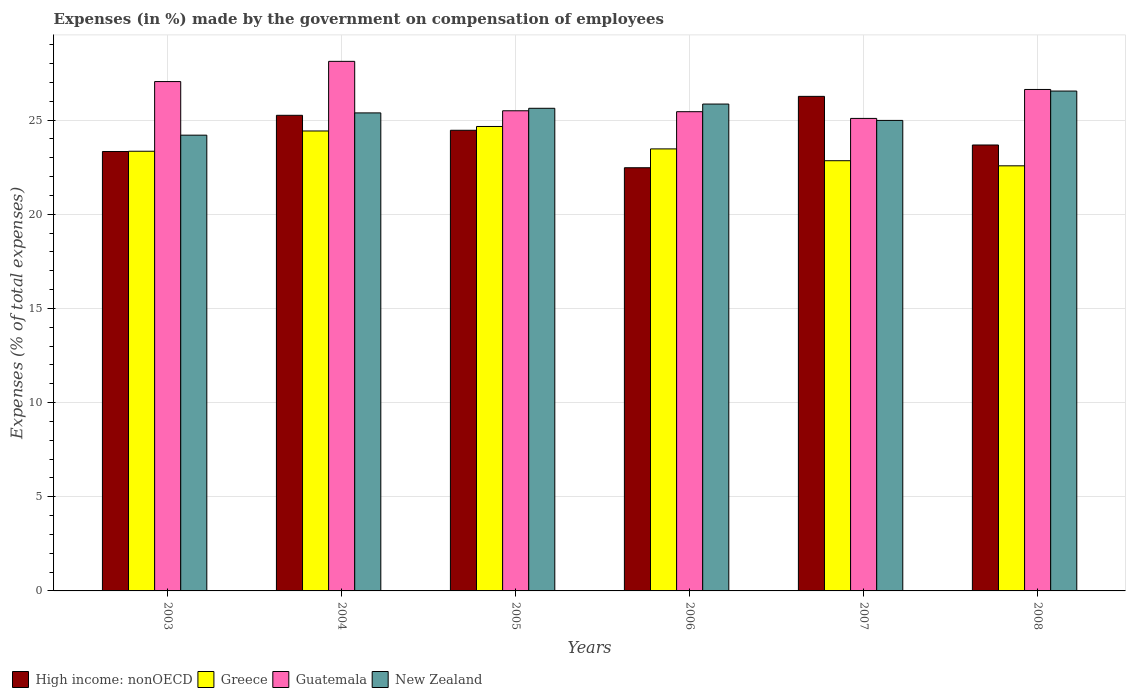How many different coloured bars are there?
Make the answer very short. 4. How many groups of bars are there?
Provide a short and direct response. 6. Are the number of bars per tick equal to the number of legend labels?
Your answer should be very brief. Yes. Are the number of bars on each tick of the X-axis equal?
Your response must be concise. Yes. How many bars are there on the 3rd tick from the left?
Offer a very short reply. 4. How many bars are there on the 3rd tick from the right?
Your answer should be compact. 4. In how many cases, is the number of bars for a given year not equal to the number of legend labels?
Ensure brevity in your answer.  0. What is the percentage of expenses made by the government on compensation of employees in Guatemala in 2005?
Give a very brief answer. 25.49. Across all years, what is the maximum percentage of expenses made by the government on compensation of employees in Greece?
Provide a short and direct response. 24.66. Across all years, what is the minimum percentage of expenses made by the government on compensation of employees in New Zealand?
Ensure brevity in your answer.  24.2. In which year was the percentage of expenses made by the government on compensation of employees in Guatemala maximum?
Provide a succinct answer. 2004. In which year was the percentage of expenses made by the government on compensation of employees in Guatemala minimum?
Keep it short and to the point. 2007. What is the total percentage of expenses made by the government on compensation of employees in Greece in the graph?
Offer a terse response. 141.3. What is the difference between the percentage of expenses made by the government on compensation of employees in High income: nonOECD in 2003 and that in 2004?
Provide a succinct answer. -1.92. What is the difference between the percentage of expenses made by the government on compensation of employees in New Zealand in 2007 and the percentage of expenses made by the government on compensation of employees in Guatemala in 2004?
Give a very brief answer. -3.14. What is the average percentage of expenses made by the government on compensation of employees in High income: nonOECD per year?
Give a very brief answer. 24.24. In the year 2005, what is the difference between the percentage of expenses made by the government on compensation of employees in New Zealand and percentage of expenses made by the government on compensation of employees in Greece?
Make the answer very short. 0.97. What is the ratio of the percentage of expenses made by the government on compensation of employees in New Zealand in 2003 to that in 2006?
Offer a terse response. 0.94. Is the percentage of expenses made by the government on compensation of employees in Greece in 2003 less than that in 2007?
Offer a very short reply. No. Is the difference between the percentage of expenses made by the government on compensation of employees in New Zealand in 2006 and 2008 greater than the difference between the percentage of expenses made by the government on compensation of employees in Greece in 2006 and 2008?
Offer a very short reply. No. What is the difference between the highest and the second highest percentage of expenses made by the government on compensation of employees in Greece?
Your answer should be very brief. 0.24. What is the difference between the highest and the lowest percentage of expenses made by the government on compensation of employees in High income: nonOECD?
Your response must be concise. 3.79. In how many years, is the percentage of expenses made by the government on compensation of employees in New Zealand greater than the average percentage of expenses made by the government on compensation of employees in New Zealand taken over all years?
Keep it short and to the point. 3. Is the sum of the percentage of expenses made by the government on compensation of employees in High income: nonOECD in 2003 and 2004 greater than the maximum percentage of expenses made by the government on compensation of employees in Greece across all years?
Your response must be concise. Yes. What does the 3rd bar from the left in 2007 represents?
Your answer should be very brief. Guatemala. What does the 1st bar from the right in 2003 represents?
Your response must be concise. New Zealand. What is the difference between two consecutive major ticks on the Y-axis?
Provide a short and direct response. 5. Does the graph contain grids?
Your answer should be compact. Yes. Where does the legend appear in the graph?
Your response must be concise. Bottom left. What is the title of the graph?
Provide a succinct answer. Expenses (in %) made by the government on compensation of employees. Does "Papua New Guinea" appear as one of the legend labels in the graph?
Ensure brevity in your answer.  No. What is the label or title of the X-axis?
Ensure brevity in your answer.  Years. What is the label or title of the Y-axis?
Your answer should be compact. Expenses (% of total expenses). What is the Expenses (% of total expenses) of High income: nonOECD in 2003?
Provide a short and direct response. 23.33. What is the Expenses (% of total expenses) of Greece in 2003?
Provide a short and direct response. 23.34. What is the Expenses (% of total expenses) of Guatemala in 2003?
Provide a succinct answer. 27.04. What is the Expenses (% of total expenses) of New Zealand in 2003?
Provide a short and direct response. 24.2. What is the Expenses (% of total expenses) of High income: nonOECD in 2004?
Provide a short and direct response. 25.25. What is the Expenses (% of total expenses) of Greece in 2004?
Give a very brief answer. 24.42. What is the Expenses (% of total expenses) in Guatemala in 2004?
Give a very brief answer. 28.12. What is the Expenses (% of total expenses) of New Zealand in 2004?
Offer a terse response. 25.38. What is the Expenses (% of total expenses) of High income: nonOECD in 2005?
Your answer should be compact. 24.46. What is the Expenses (% of total expenses) of Greece in 2005?
Your answer should be compact. 24.66. What is the Expenses (% of total expenses) of Guatemala in 2005?
Give a very brief answer. 25.49. What is the Expenses (% of total expenses) in New Zealand in 2005?
Your response must be concise. 25.62. What is the Expenses (% of total expenses) of High income: nonOECD in 2006?
Make the answer very short. 22.47. What is the Expenses (% of total expenses) in Greece in 2006?
Provide a short and direct response. 23.47. What is the Expenses (% of total expenses) in Guatemala in 2006?
Provide a short and direct response. 25.44. What is the Expenses (% of total expenses) in New Zealand in 2006?
Ensure brevity in your answer.  25.85. What is the Expenses (% of total expenses) of High income: nonOECD in 2007?
Give a very brief answer. 26.26. What is the Expenses (% of total expenses) in Greece in 2007?
Offer a very short reply. 22.84. What is the Expenses (% of total expenses) of Guatemala in 2007?
Offer a very short reply. 25.09. What is the Expenses (% of total expenses) of New Zealand in 2007?
Keep it short and to the point. 24.98. What is the Expenses (% of total expenses) in High income: nonOECD in 2008?
Provide a succinct answer. 23.67. What is the Expenses (% of total expenses) of Greece in 2008?
Your answer should be very brief. 22.57. What is the Expenses (% of total expenses) in Guatemala in 2008?
Offer a very short reply. 26.62. What is the Expenses (% of total expenses) of New Zealand in 2008?
Give a very brief answer. 26.54. Across all years, what is the maximum Expenses (% of total expenses) of High income: nonOECD?
Make the answer very short. 26.26. Across all years, what is the maximum Expenses (% of total expenses) of Greece?
Keep it short and to the point. 24.66. Across all years, what is the maximum Expenses (% of total expenses) in Guatemala?
Give a very brief answer. 28.12. Across all years, what is the maximum Expenses (% of total expenses) of New Zealand?
Make the answer very short. 26.54. Across all years, what is the minimum Expenses (% of total expenses) in High income: nonOECD?
Provide a short and direct response. 22.47. Across all years, what is the minimum Expenses (% of total expenses) in Greece?
Keep it short and to the point. 22.57. Across all years, what is the minimum Expenses (% of total expenses) of Guatemala?
Offer a terse response. 25.09. Across all years, what is the minimum Expenses (% of total expenses) in New Zealand?
Make the answer very short. 24.2. What is the total Expenses (% of total expenses) in High income: nonOECD in the graph?
Ensure brevity in your answer.  145.43. What is the total Expenses (% of total expenses) in Greece in the graph?
Your response must be concise. 141.3. What is the total Expenses (% of total expenses) of Guatemala in the graph?
Your answer should be compact. 157.8. What is the total Expenses (% of total expenses) in New Zealand in the graph?
Ensure brevity in your answer.  152.56. What is the difference between the Expenses (% of total expenses) in High income: nonOECD in 2003 and that in 2004?
Offer a terse response. -1.92. What is the difference between the Expenses (% of total expenses) in Greece in 2003 and that in 2004?
Your answer should be very brief. -1.08. What is the difference between the Expenses (% of total expenses) of Guatemala in 2003 and that in 2004?
Ensure brevity in your answer.  -1.07. What is the difference between the Expenses (% of total expenses) of New Zealand in 2003 and that in 2004?
Your answer should be very brief. -1.18. What is the difference between the Expenses (% of total expenses) of High income: nonOECD in 2003 and that in 2005?
Your answer should be very brief. -1.13. What is the difference between the Expenses (% of total expenses) in Greece in 2003 and that in 2005?
Your answer should be very brief. -1.31. What is the difference between the Expenses (% of total expenses) of Guatemala in 2003 and that in 2005?
Make the answer very short. 1.55. What is the difference between the Expenses (% of total expenses) in New Zealand in 2003 and that in 2005?
Your answer should be very brief. -1.43. What is the difference between the Expenses (% of total expenses) of High income: nonOECD in 2003 and that in 2006?
Your answer should be compact. 0.86. What is the difference between the Expenses (% of total expenses) of Greece in 2003 and that in 2006?
Make the answer very short. -0.12. What is the difference between the Expenses (% of total expenses) of Guatemala in 2003 and that in 2006?
Give a very brief answer. 1.6. What is the difference between the Expenses (% of total expenses) in New Zealand in 2003 and that in 2006?
Your response must be concise. -1.65. What is the difference between the Expenses (% of total expenses) of High income: nonOECD in 2003 and that in 2007?
Offer a very short reply. -2.93. What is the difference between the Expenses (% of total expenses) of Greece in 2003 and that in 2007?
Your response must be concise. 0.5. What is the difference between the Expenses (% of total expenses) of Guatemala in 2003 and that in 2007?
Offer a very short reply. 1.96. What is the difference between the Expenses (% of total expenses) in New Zealand in 2003 and that in 2007?
Your response must be concise. -0.78. What is the difference between the Expenses (% of total expenses) of High income: nonOECD in 2003 and that in 2008?
Give a very brief answer. -0.34. What is the difference between the Expenses (% of total expenses) of Greece in 2003 and that in 2008?
Give a very brief answer. 0.77. What is the difference between the Expenses (% of total expenses) of Guatemala in 2003 and that in 2008?
Provide a short and direct response. 0.42. What is the difference between the Expenses (% of total expenses) in New Zealand in 2003 and that in 2008?
Keep it short and to the point. -2.34. What is the difference between the Expenses (% of total expenses) in High income: nonOECD in 2004 and that in 2005?
Offer a very short reply. 0.79. What is the difference between the Expenses (% of total expenses) in Greece in 2004 and that in 2005?
Your answer should be very brief. -0.24. What is the difference between the Expenses (% of total expenses) of Guatemala in 2004 and that in 2005?
Your answer should be compact. 2.62. What is the difference between the Expenses (% of total expenses) in New Zealand in 2004 and that in 2005?
Your response must be concise. -0.25. What is the difference between the Expenses (% of total expenses) in High income: nonOECD in 2004 and that in 2006?
Ensure brevity in your answer.  2.78. What is the difference between the Expenses (% of total expenses) of Greece in 2004 and that in 2006?
Provide a short and direct response. 0.95. What is the difference between the Expenses (% of total expenses) of Guatemala in 2004 and that in 2006?
Provide a succinct answer. 2.67. What is the difference between the Expenses (% of total expenses) in New Zealand in 2004 and that in 2006?
Offer a very short reply. -0.47. What is the difference between the Expenses (% of total expenses) in High income: nonOECD in 2004 and that in 2007?
Your response must be concise. -1.01. What is the difference between the Expenses (% of total expenses) in Greece in 2004 and that in 2007?
Offer a terse response. 1.58. What is the difference between the Expenses (% of total expenses) of Guatemala in 2004 and that in 2007?
Make the answer very short. 3.03. What is the difference between the Expenses (% of total expenses) of New Zealand in 2004 and that in 2007?
Provide a succinct answer. 0.4. What is the difference between the Expenses (% of total expenses) in High income: nonOECD in 2004 and that in 2008?
Provide a succinct answer. 1.58. What is the difference between the Expenses (% of total expenses) in Greece in 2004 and that in 2008?
Your answer should be compact. 1.85. What is the difference between the Expenses (% of total expenses) in Guatemala in 2004 and that in 2008?
Keep it short and to the point. 1.49. What is the difference between the Expenses (% of total expenses) in New Zealand in 2004 and that in 2008?
Give a very brief answer. -1.16. What is the difference between the Expenses (% of total expenses) of High income: nonOECD in 2005 and that in 2006?
Offer a terse response. 1.99. What is the difference between the Expenses (% of total expenses) of Greece in 2005 and that in 2006?
Your response must be concise. 1.19. What is the difference between the Expenses (% of total expenses) of Guatemala in 2005 and that in 2006?
Make the answer very short. 0.05. What is the difference between the Expenses (% of total expenses) of New Zealand in 2005 and that in 2006?
Offer a terse response. -0.22. What is the difference between the Expenses (% of total expenses) of High income: nonOECD in 2005 and that in 2007?
Ensure brevity in your answer.  -1.8. What is the difference between the Expenses (% of total expenses) in Greece in 2005 and that in 2007?
Provide a short and direct response. 1.82. What is the difference between the Expenses (% of total expenses) of Guatemala in 2005 and that in 2007?
Keep it short and to the point. 0.41. What is the difference between the Expenses (% of total expenses) of New Zealand in 2005 and that in 2007?
Your answer should be compact. 0.64. What is the difference between the Expenses (% of total expenses) in High income: nonOECD in 2005 and that in 2008?
Keep it short and to the point. 0.78. What is the difference between the Expenses (% of total expenses) of Greece in 2005 and that in 2008?
Provide a succinct answer. 2.09. What is the difference between the Expenses (% of total expenses) in Guatemala in 2005 and that in 2008?
Your response must be concise. -1.13. What is the difference between the Expenses (% of total expenses) in New Zealand in 2005 and that in 2008?
Make the answer very short. -0.91. What is the difference between the Expenses (% of total expenses) of High income: nonOECD in 2006 and that in 2007?
Make the answer very short. -3.79. What is the difference between the Expenses (% of total expenses) of Greece in 2006 and that in 2007?
Offer a terse response. 0.63. What is the difference between the Expenses (% of total expenses) in Guatemala in 2006 and that in 2007?
Offer a very short reply. 0.36. What is the difference between the Expenses (% of total expenses) of New Zealand in 2006 and that in 2007?
Make the answer very short. 0.87. What is the difference between the Expenses (% of total expenses) in High income: nonOECD in 2006 and that in 2008?
Ensure brevity in your answer.  -1.21. What is the difference between the Expenses (% of total expenses) of Greece in 2006 and that in 2008?
Offer a very short reply. 0.9. What is the difference between the Expenses (% of total expenses) of Guatemala in 2006 and that in 2008?
Provide a succinct answer. -1.18. What is the difference between the Expenses (% of total expenses) in New Zealand in 2006 and that in 2008?
Offer a very short reply. -0.69. What is the difference between the Expenses (% of total expenses) of High income: nonOECD in 2007 and that in 2008?
Make the answer very short. 2.58. What is the difference between the Expenses (% of total expenses) in Greece in 2007 and that in 2008?
Your response must be concise. 0.27. What is the difference between the Expenses (% of total expenses) in Guatemala in 2007 and that in 2008?
Make the answer very short. -1.54. What is the difference between the Expenses (% of total expenses) of New Zealand in 2007 and that in 2008?
Ensure brevity in your answer.  -1.56. What is the difference between the Expenses (% of total expenses) of High income: nonOECD in 2003 and the Expenses (% of total expenses) of Greece in 2004?
Give a very brief answer. -1.09. What is the difference between the Expenses (% of total expenses) of High income: nonOECD in 2003 and the Expenses (% of total expenses) of Guatemala in 2004?
Ensure brevity in your answer.  -4.79. What is the difference between the Expenses (% of total expenses) in High income: nonOECD in 2003 and the Expenses (% of total expenses) in New Zealand in 2004?
Give a very brief answer. -2.05. What is the difference between the Expenses (% of total expenses) in Greece in 2003 and the Expenses (% of total expenses) in Guatemala in 2004?
Make the answer very short. -4.77. What is the difference between the Expenses (% of total expenses) in Greece in 2003 and the Expenses (% of total expenses) in New Zealand in 2004?
Offer a terse response. -2.04. What is the difference between the Expenses (% of total expenses) in Guatemala in 2003 and the Expenses (% of total expenses) in New Zealand in 2004?
Provide a short and direct response. 1.66. What is the difference between the Expenses (% of total expenses) in High income: nonOECD in 2003 and the Expenses (% of total expenses) in Greece in 2005?
Provide a short and direct response. -1.33. What is the difference between the Expenses (% of total expenses) in High income: nonOECD in 2003 and the Expenses (% of total expenses) in Guatemala in 2005?
Your answer should be compact. -2.16. What is the difference between the Expenses (% of total expenses) in High income: nonOECD in 2003 and the Expenses (% of total expenses) in New Zealand in 2005?
Your response must be concise. -2.29. What is the difference between the Expenses (% of total expenses) in Greece in 2003 and the Expenses (% of total expenses) in Guatemala in 2005?
Ensure brevity in your answer.  -2.15. What is the difference between the Expenses (% of total expenses) of Greece in 2003 and the Expenses (% of total expenses) of New Zealand in 2005?
Offer a terse response. -2.28. What is the difference between the Expenses (% of total expenses) in Guatemala in 2003 and the Expenses (% of total expenses) in New Zealand in 2005?
Make the answer very short. 1.42. What is the difference between the Expenses (% of total expenses) in High income: nonOECD in 2003 and the Expenses (% of total expenses) in Greece in 2006?
Give a very brief answer. -0.14. What is the difference between the Expenses (% of total expenses) of High income: nonOECD in 2003 and the Expenses (% of total expenses) of Guatemala in 2006?
Make the answer very short. -2.11. What is the difference between the Expenses (% of total expenses) of High income: nonOECD in 2003 and the Expenses (% of total expenses) of New Zealand in 2006?
Your answer should be very brief. -2.52. What is the difference between the Expenses (% of total expenses) of Greece in 2003 and the Expenses (% of total expenses) of Guatemala in 2006?
Make the answer very short. -2.1. What is the difference between the Expenses (% of total expenses) of Greece in 2003 and the Expenses (% of total expenses) of New Zealand in 2006?
Provide a succinct answer. -2.51. What is the difference between the Expenses (% of total expenses) in Guatemala in 2003 and the Expenses (% of total expenses) in New Zealand in 2006?
Make the answer very short. 1.19. What is the difference between the Expenses (% of total expenses) in High income: nonOECD in 2003 and the Expenses (% of total expenses) in Greece in 2007?
Make the answer very short. 0.49. What is the difference between the Expenses (% of total expenses) in High income: nonOECD in 2003 and the Expenses (% of total expenses) in Guatemala in 2007?
Provide a short and direct response. -1.76. What is the difference between the Expenses (% of total expenses) in High income: nonOECD in 2003 and the Expenses (% of total expenses) in New Zealand in 2007?
Provide a succinct answer. -1.65. What is the difference between the Expenses (% of total expenses) in Greece in 2003 and the Expenses (% of total expenses) in Guatemala in 2007?
Your answer should be very brief. -1.74. What is the difference between the Expenses (% of total expenses) of Greece in 2003 and the Expenses (% of total expenses) of New Zealand in 2007?
Your answer should be very brief. -1.64. What is the difference between the Expenses (% of total expenses) in Guatemala in 2003 and the Expenses (% of total expenses) in New Zealand in 2007?
Ensure brevity in your answer.  2.06. What is the difference between the Expenses (% of total expenses) in High income: nonOECD in 2003 and the Expenses (% of total expenses) in Greece in 2008?
Your answer should be very brief. 0.76. What is the difference between the Expenses (% of total expenses) of High income: nonOECD in 2003 and the Expenses (% of total expenses) of Guatemala in 2008?
Offer a terse response. -3.29. What is the difference between the Expenses (% of total expenses) in High income: nonOECD in 2003 and the Expenses (% of total expenses) in New Zealand in 2008?
Give a very brief answer. -3.21. What is the difference between the Expenses (% of total expenses) of Greece in 2003 and the Expenses (% of total expenses) of Guatemala in 2008?
Provide a short and direct response. -3.28. What is the difference between the Expenses (% of total expenses) in Greece in 2003 and the Expenses (% of total expenses) in New Zealand in 2008?
Make the answer very short. -3.2. What is the difference between the Expenses (% of total expenses) of Guatemala in 2003 and the Expenses (% of total expenses) of New Zealand in 2008?
Your answer should be very brief. 0.5. What is the difference between the Expenses (% of total expenses) of High income: nonOECD in 2004 and the Expenses (% of total expenses) of Greece in 2005?
Offer a terse response. 0.59. What is the difference between the Expenses (% of total expenses) of High income: nonOECD in 2004 and the Expenses (% of total expenses) of Guatemala in 2005?
Offer a very short reply. -0.24. What is the difference between the Expenses (% of total expenses) in High income: nonOECD in 2004 and the Expenses (% of total expenses) in New Zealand in 2005?
Your answer should be compact. -0.37. What is the difference between the Expenses (% of total expenses) in Greece in 2004 and the Expenses (% of total expenses) in Guatemala in 2005?
Provide a succinct answer. -1.07. What is the difference between the Expenses (% of total expenses) of Greece in 2004 and the Expenses (% of total expenses) of New Zealand in 2005?
Ensure brevity in your answer.  -1.2. What is the difference between the Expenses (% of total expenses) in Guatemala in 2004 and the Expenses (% of total expenses) in New Zealand in 2005?
Your answer should be compact. 2.49. What is the difference between the Expenses (% of total expenses) of High income: nonOECD in 2004 and the Expenses (% of total expenses) of Greece in 2006?
Provide a short and direct response. 1.78. What is the difference between the Expenses (% of total expenses) in High income: nonOECD in 2004 and the Expenses (% of total expenses) in Guatemala in 2006?
Provide a short and direct response. -0.19. What is the difference between the Expenses (% of total expenses) in High income: nonOECD in 2004 and the Expenses (% of total expenses) in New Zealand in 2006?
Offer a very short reply. -0.6. What is the difference between the Expenses (% of total expenses) of Greece in 2004 and the Expenses (% of total expenses) of Guatemala in 2006?
Give a very brief answer. -1.02. What is the difference between the Expenses (% of total expenses) in Greece in 2004 and the Expenses (% of total expenses) in New Zealand in 2006?
Your answer should be compact. -1.43. What is the difference between the Expenses (% of total expenses) in Guatemala in 2004 and the Expenses (% of total expenses) in New Zealand in 2006?
Give a very brief answer. 2.27. What is the difference between the Expenses (% of total expenses) of High income: nonOECD in 2004 and the Expenses (% of total expenses) of Greece in 2007?
Your response must be concise. 2.41. What is the difference between the Expenses (% of total expenses) of High income: nonOECD in 2004 and the Expenses (% of total expenses) of Guatemala in 2007?
Provide a short and direct response. 0.17. What is the difference between the Expenses (% of total expenses) in High income: nonOECD in 2004 and the Expenses (% of total expenses) in New Zealand in 2007?
Ensure brevity in your answer.  0.27. What is the difference between the Expenses (% of total expenses) in Greece in 2004 and the Expenses (% of total expenses) in Guatemala in 2007?
Ensure brevity in your answer.  -0.67. What is the difference between the Expenses (% of total expenses) of Greece in 2004 and the Expenses (% of total expenses) of New Zealand in 2007?
Your response must be concise. -0.56. What is the difference between the Expenses (% of total expenses) of Guatemala in 2004 and the Expenses (% of total expenses) of New Zealand in 2007?
Provide a succinct answer. 3.14. What is the difference between the Expenses (% of total expenses) in High income: nonOECD in 2004 and the Expenses (% of total expenses) in Greece in 2008?
Offer a very short reply. 2.68. What is the difference between the Expenses (% of total expenses) of High income: nonOECD in 2004 and the Expenses (% of total expenses) of Guatemala in 2008?
Keep it short and to the point. -1.37. What is the difference between the Expenses (% of total expenses) in High income: nonOECD in 2004 and the Expenses (% of total expenses) in New Zealand in 2008?
Provide a short and direct response. -1.29. What is the difference between the Expenses (% of total expenses) of Greece in 2004 and the Expenses (% of total expenses) of Guatemala in 2008?
Make the answer very short. -2.2. What is the difference between the Expenses (% of total expenses) of Greece in 2004 and the Expenses (% of total expenses) of New Zealand in 2008?
Give a very brief answer. -2.12. What is the difference between the Expenses (% of total expenses) in Guatemala in 2004 and the Expenses (% of total expenses) in New Zealand in 2008?
Make the answer very short. 1.58. What is the difference between the Expenses (% of total expenses) in High income: nonOECD in 2005 and the Expenses (% of total expenses) in Greece in 2006?
Provide a short and direct response. 0.99. What is the difference between the Expenses (% of total expenses) of High income: nonOECD in 2005 and the Expenses (% of total expenses) of Guatemala in 2006?
Keep it short and to the point. -0.99. What is the difference between the Expenses (% of total expenses) in High income: nonOECD in 2005 and the Expenses (% of total expenses) in New Zealand in 2006?
Provide a short and direct response. -1.39. What is the difference between the Expenses (% of total expenses) of Greece in 2005 and the Expenses (% of total expenses) of Guatemala in 2006?
Keep it short and to the point. -0.79. What is the difference between the Expenses (% of total expenses) of Greece in 2005 and the Expenses (% of total expenses) of New Zealand in 2006?
Offer a terse response. -1.19. What is the difference between the Expenses (% of total expenses) of Guatemala in 2005 and the Expenses (% of total expenses) of New Zealand in 2006?
Make the answer very short. -0.36. What is the difference between the Expenses (% of total expenses) in High income: nonOECD in 2005 and the Expenses (% of total expenses) in Greece in 2007?
Give a very brief answer. 1.62. What is the difference between the Expenses (% of total expenses) in High income: nonOECD in 2005 and the Expenses (% of total expenses) in Guatemala in 2007?
Provide a short and direct response. -0.63. What is the difference between the Expenses (% of total expenses) in High income: nonOECD in 2005 and the Expenses (% of total expenses) in New Zealand in 2007?
Ensure brevity in your answer.  -0.52. What is the difference between the Expenses (% of total expenses) of Greece in 2005 and the Expenses (% of total expenses) of Guatemala in 2007?
Offer a terse response. -0.43. What is the difference between the Expenses (% of total expenses) in Greece in 2005 and the Expenses (% of total expenses) in New Zealand in 2007?
Provide a succinct answer. -0.32. What is the difference between the Expenses (% of total expenses) of Guatemala in 2005 and the Expenses (% of total expenses) of New Zealand in 2007?
Offer a very short reply. 0.51. What is the difference between the Expenses (% of total expenses) in High income: nonOECD in 2005 and the Expenses (% of total expenses) in Greece in 2008?
Make the answer very short. 1.89. What is the difference between the Expenses (% of total expenses) in High income: nonOECD in 2005 and the Expenses (% of total expenses) in Guatemala in 2008?
Make the answer very short. -2.17. What is the difference between the Expenses (% of total expenses) in High income: nonOECD in 2005 and the Expenses (% of total expenses) in New Zealand in 2008?
Your response must be concise. -2.08. What is the difference between the Expenses (% of total expenses) of Greece in 2005 and the Expenses (% of total expenses) of Guatemala in 2008?
Provide a short and direct response. -1.97. What is the difference between the Expenses (% of total expenses) in Greece in 2005 and the Expenses (% of total expenses) in New Zealand in 2008?
Make the answer very short. -1.88. What is the difference between the Expenses (% of total expenses) of Guatemala in 2005 and the Expenses (% of total expenses) of New Zealand in 2008?
Provide a short and direct response. -1.05. What is the difference between the Expenses (% of total expenses) in High income: nonOECD in 2006 and the Expenses (% of total expenses) in Greece in 2007?
Offer a very short reply. -0.37. What is the difference between the Expenses (% of total expenses) of High income: nonOECD in 2006 and the Expenses (% of total expenses) of Guatemala in 2007?
Offer a terse response. -2.62. What is the difference between the Expenses (% of total expenses) of High income: nonOECD in 2006 and the Expenses (% of total expenses) of New Zealand in 2007?
Your answer should be very brief. -2.51. What is the difference between the Expenses (% of total expenses) of Greece in 2006 and the Expenses (% of total expenses) of Guatemala in 2007?
Give a very brief answer. -1.62. What is the difference between the Expenses (% of total expenses) of Greece in 2006 and the Expenses (% of total expenses) of New Zealand in 2007?
Provide a short and direct response. -1.51. What is the difference between the Expenses (% of total expenses) in Guatemala in 2006 and the Expenses (% of total expenses) in New Zealand in 2007?
Keep it short and to the point. 0.46. What is the difference between the Expenses (% of total expenses) in High income: nonOECD in 2006 and the Expenses (% of total expenses) in Greece in 2008?
Provide a short and direct response. -0.1. What is the difference between the Expenses (% of total expenses) in High income: nonOECD in 2006 and the Expenses (% of total expenses) in Guatemala in 2008?
Offer a very short reply. -4.16. What is the difference between the Expenses (% of total expenses) of High income: nonOECD in 2006 and the Expenses (% of total expenses) of New Zealand in 2008?
Give a very brief answer. -4.07. What is the difference between the Expenses (% of total expenses) in Greece in 2006 and the Expenses (% of total expenses) in Guatemala in 2008?
Your answer should be very brief. -3.16. What is the difference between the Expenses (% of total expenses) in Greece in 2006 and the Expenses (% of total expenses) in New Zealand in 2008?
Your answer should be very brief. -3.07. What is the difference between the Expenses (% of total expenses) of Guatemala in 2006 and the Expenses (% of total expenses) of New Zealand in 2008?
Offer a terse response. -1.1. What is the difference between the Expenses (% of total expenses) in High income: nonOECD in 2007 and the Expenses (% of total expenses) in Greece in 2008?
Ensure brevity in your answer.  3.69. What is the difference between the Expenses (% of total expenses) in High income: nonOECD in 2007 and the Expenses (% of total expenses) in Guatemala in 2008?
Provide a short and direct response. -0.37. What is the difference between the Expenses (% of total expenses) of High income: nonOECD in 2007 and the Expenses (% of total expenses) of New Zealand in 2008?
Make the answer very short. -0.28. What is the difference between the Expenses (% of total expenses) of Greece in 2007 and the Expenses (% of total expenses) of Guatemala in 2008?
Your answer should be very brief. -3.78. What is the difference between the Expenses (% of total expenses) in Greece in 2007 and the Expenses (% of total expenses) in New Zealand in 2008?
Offer a terse response. -3.7. What is the difference between the Expenses (% of total expenses) of Guatemala in 2007 and the Expenses (% of total expenses) of New Zealand in 2008?
Offer a terse response. -1.45. What is the average Expenses (% of total expenses) in High income: nonOECD per year?
Keep it short and to the point. 24.24. What is the average Expenses (% of total expenses) in Greece per year?
Make the answer very short. 23.55. What is the average Expenses (% of total expenses) in Guatemala per year?
Offer a very short reply. 26.3. What is the average Expenses (% of total expenses) of New Zealand per year?
Your answer should be very brief. 25.43. In the year 2003, what is the difference between the Expenses (% of total expenses) of High income: nonOECD and Expenses (% of total expenses) of Greece?
Give a very brief answer. -0.01. In the year 2003, what is the difference between the Expenses (% of total expenses) in High income: nonOECD and Expenses (% of total expenses) in Guatemala?
Ensure brevity in your answer.  -3.71. In the year 2003, what is the difference between the Expenses (% of total expenses) in High income: nonOECD and Expenses (% of total expenses) in New Zealand?
Offer a terse response. -0.87. In the year 2003, what is the difference between the Expenses (% of total expenses) of Greece and Expenses (% of total expenses) of Guatemala?
Your answer should be very brief. -3.7. In the year 2003, what is the difference between the Expenses (% of total expenses) in Greece and Expenses (% of total expenses) in New Zealand?
Ensure brevity in your answer.  -0.85. In the year 2003, what is the difference between the Expenses (% of total expenses) of Guatemala and Expenses (% of total expenses) of New Zealand?
Provide a succinct answer. 2.85. In the year 2004, what is the difference between the Expenses (% of total expenses) in High income: nonOECD and Expenses (% of total expenses) in Greece?
Your answer should be very brief. 0.83. In the year 2004, what is the difference between the Expenses (% of total expenses) in High income: nonOECD and Expenses (% of total expenses) in Guatemala?
Give a very brief answer. -2.86. In the year 2004, what is the difference between the Expenses (% of total expenses) in High income: nonOECD and Expenses (% of total expenses) in New Zealand?
Your answer should be compact. -0.13. In the year 2004, what is the difference between the Expenses (% of total expenses) in Greece and Expenses (% of total expenses) in Guatemala?
Your answer should be very brief. -3.7. In the year 2004, what is the difference between the Expenses (% of total expenses) in Greece and Expenses (% of total expenses) in New Zealand?
Your answer should be very brief. -0.96. In the year 2004, what is the difference between the Expenses (% of total expenses) in Guatemala and Expenses (% of total expenses) in New Zealand?
Provide a short and direct response. 2.74. In the year 2005, what is the difference between the Expenses (% of total expenses) in High income: nonOECD and Expenses (% of total expenses) in Greece?
Provide a succinct answer. -0.2. In the year 2005, what is the difference between the Expenses (% of total expenses) in High income: nonOECD and Expenses (% of total expenses) in Guatemala?
Ensure brevity in your answer.  -1.03. In the year 2005, what is the difference between the Expenses (% of total expenses) in High income: nonOECD and Expenses (% of total expenses) in New Zealand?
Give a very brief answer. -1.17. In the year 2005, what is the difference between the Expenses (% of total expenses) of Greece and Expenses (% of total expenses) of Guatemala?
Your answer should be compact. -0.83. In the year 2005, what is the difference between the Expenses (% of total expenses) in Greece and Expenses (% of total expenses) in New Zealand?
Your response must be concise. -0.97. In the year 2005, what is the difference between the Expenses (% of total expenses) of Guatemala and Expenses (% of total expenses) of New Zealand?
Your answer should be compact. -0.13. In the year 2006, what is the difference between the Expenses (% of total expenses) of High income: nonOECD and Expenses (% of total expenses) of Greece?
Ensure brevity in your answer.  -1. In the year 2006, what is the difference between the Expenses (% of total expenses) in High income: nonOECD and Expenses (% of total expenses) in Guatemala?
Offer a very short reply. -2.98. In the year 2006, what is the difference between the Expenses (% of total expenses) in High income: nonOECD and Expenses (% of total expenses) in New Zealand?
Your answer should be compact. -3.38. In the year 2006, what is the difference between the Expenses (% of total expenses) of Greece and Expenses (% of total expenses) of Guatemala?
Provide a succinct answer. -1.98. In the year 2006, what is the difference between the Expenses (% of total expenses) of Greece and Expenses (% of total expenses) of New Zealand?
Give a very brief answer. -2.38. In the year 2006, what is the difference between the Expenses (% of total expenses) in Guatemala and Expenses (% of total expenses) in New Zealand?
Provide a succinct answer. -0.41. In the year 2007, what is the difference between the Expenses (% of total expenses) of High income: nonOECD and Expenses (% of total expenses) of Greece?
Offer a very short reply. 3.42. In the year 2007, what is the difference between the Expenses (% of total expenses) in High income: nonOECD and Expenses (% of total expenses) in Guatemala?
Your answer should be compact. 1.17. In the year 2007, what is the difference between the Expenses (% of total expenses) in High income: nonOECD and Expenses (% of total expenses) in New Zealand?
Your answer should be very brief. 1.28. In the year 2007, what is the difference between the Expenses (% of total expenses) in Greece and Expenses (% of total expenses) in Guatemala?
Your answer should be very brief. -2.25. In the year 2007, what is the difference between the Expenses (% of total expenses) of Greece and Expenses (% of total expenses) of New Zealand?
Make the answer very short. -2.14. In the year 2007, what is the difference between the Expenses (% of total expenses) in Guatemala and Expenses (% of total expenses) in New Zealand?
Ensure brevity in your answer.  0.11. In the year 2008, what is the difference between the Expenses (% of total expenses) in High income: nonOECD and Expenses (% of total expenses) in Greece?
Ensure brevity in your answer.  1.11. In the year 2008, what is the difference between the Expenses (% of total expenses) in High income: nonOECD and Expenses (% of total expenses) in Guatemala?
Your response must be concise. -2.95. In the year 2008, what is the difference between the Expenses (% of total expenses) of High income: nonOECD and Expenses (% of total expenses) of New Zealand?
Offer a very short reply. -2.86. In the year 2008, what is the difference between the Expenses (% of total expenses) in Greece and Expenses (% of total expenses) in Guatemala?
Offer a terse response. -4.05. In the year 2008, what is the difference between the Expenses (% of total expenses) of Greece and Expenses (% of total expenses) of New Zealand?
Your answer should be very brief. -3.97. In the year 2008, what is the difference between the Expenses (% of total expenses) of Guatemala and Expenses (% of total expenses) of New Zealand?
Offer a terse response. 0.08. What is the ratio of the Expenses (% of total expenses) in High income: nonOECD in 2003 to that in 2004?
Your answer should be very brief. 0.92. What is the ratio of the Expenses (% of total expenses) of Greece in 2003 to that in 2004?
Ensure brevity in your answer.  0.96. What is the ratio of the Expenses (% of total expenses) in Guatemala in 2003 to that in 2004?
Keep it short and to the point. 0.96. What is the ratio of the Expenses (% of total expenses) of New Zealand in 2003 to that in 2004?
Your response must be concise. 0.95. What is the ratio of the Expenses (% of total expenses) of High income: nonOECD in 2003 to that in 2005?
Your answer should be compact. 0.95. What is the ratio of the Expenses (% of total expenses) in Greece in 2003 to that in 2005?
Keep it short and to the point. 0.95. What is the ratio of the Expenses (% of total expenses) in Guatemala in 2003 to that in 2005?
Ensure brevity in your answer.  1.06. What is the ratio of the Expenses (% of total expenses) of New Zealand in 2003 to that in 2005?
Your response must be concise. 0.94. What is the ratio of the Expenses (% of total expenses) of High income: nonOECD in 2003 to that in 2006?
Make the answer very short. 1.04. What is the ratio of the Expenses (% of total expenses) of Guatemala in 2003 to that in 2006?
Your answer should be very brief. 1.06. What is the ratio of the Expenses (% of total expenses) in New Zealand in 2003 to that in 2006?
Offer a terse response. 0.94. What is the ratio of the Expenses (% of total expenses) in High income: nonOECD in 2003 to that in 2007?
Provide a short and direct response. 0.89. What is the ratio of the Expenses (% of total expenses) of Greece in 2003 to that in 2007?
Provide a succinct answer. 1.02. What is the ratio of the Expenses (% of total expenses) of Guatemala in 2003 to that in 2007?
Offer a terse response. 1.08. What is the ratio of the Expenses (% of total expenses) of New Zealand in 2003 to that in 2007?
Give a very brief answer. 0.97. What is the ratio of the Expenses (% of total expenses) in High income: nonOECD in 2003 to that in 2008?
Ensure brevity in your answer.  0.99. What is the ratio of the Expenses (% of total expenses) in Greece in 2003 to that in 2008?
Make the answer very short. 1.03. What is the ratio of the Expenses (% of total expenses) in Guatemala in 2003 to that in 2008?
Offer a very short reply. 1.02. What is the ratio of the Expenses (% of total expenses) in New Zealand in 2003 to that in 2008?
Offer a very short reply. 0.91. What is the ratio of the Expenses (% of total expenses) of High income: nonOECD in 2004 to that in 2005?
Make the answer very short. 1.03. What is the ratio of the Expenses (% of total expenses) of Greece in 2004 to that in 2005?
Provide a succinct answer. 0.99. What is the ratio of the Expenses (% of total expenses) in Guatemala in 2004 to that in 2005?
Your response must be concise. 1.1. What is the ratio of the Expenses (% of total expenses) of New Zealand in 2004 to that in 2005?
Ensure brevity in your answer.  0.99. What is the ratio of the Expenses (% of total expenses) in High income: nonOECD in 2004 to that in 2006?
Offer a very short reply. 1.12. What is the ratio of the Expenses (% of total expenses) of Greece in 2004 to that in 2006?
Your answer should be very brief. 1.04. What is the ratio of the Expenses (% of total expenses) of Guatemala in 2004 to that in 2006?
Provide a succinct answer. 1.1. What is the ratio of the Expenses (% of total expenses) of New Zealand in 2004 to that in 2006?
Provide a short and direct response. 0.98. What is the ratio of the Expenses (% of total expenses) in High income: nonOECD in 2004 to that in 2007?
Make the answer very short. 0.96. What is the ratio of the Expenses (% of total expenses) in Greece in 2004 to that in 2007?
Your response must be concise. 1.07. What is the ratio of the Expenses (% of total expenses) of Guatemala in 2004 to that in 2007?
Your answer should be compact. 1.12. What is the ratio of the Expenses (% of total expenses) of New Zealand in 2004 to that in 2007?
Offer a very short reply. 1.02. What is the ratio of the Expenses (% of total expenses) of High income: nonOECD in 2004 to that in 2008?
Make the answer very short. 1.07. What is the ratio of the Expenses (% of total expenses) of Greece in 2004 to that in 2008?
Offer a very short reply. 1.08. What is the ratio of the Expenses (% of total expenses) in Guatemala in 2004 to that in 2008?
Your response must be concise. 1.06. What is the ratio of the Expenses (% of total expenses) in New Zealand in 2004 to that in 2008?
Your answer should be compact. 0.96. What is the ratio of the Expenses (% of total expenses) in High income: nonOECD in 2005 to that in 2006?
Your answer should be very brief. 1.09. What is the ratio of the Expenses (% of total expenses) in Greece in 2005 to that in 2006?
Offer a terse response. 1.05. What is the ratio of the Expenses (% of total expenses) of Guatemala in 2005 to that in 2006?
Your answer should be very brief. 1. What is the ratio of the Expenses (% of total expenses) of High income: nonOECD in 2005 to that in 2007?
Make the answer very short. 0.93. What is the ratio of the Expenses (% of total expenses) in Greece in 2005 to that in 2007?
Offer a very short reply. 1.08. What is the ratio of the Expenses (% of total expenses) of Guatemala in 2005 to that in 2007?
Provide a short and direct response. 1.02. What is the ratio of the Expenses (% of total expenses) in New Zealand in 2005 to that in 2007?
Make the answer very short. 1.03. What is the ratio of the Expenses (% of total expenses) of High income: nonOECD in 2005 to that in 2008?
Provide a succinct answer. 1.03. What is the ratio of the Expenses (% of total expenses) in Greece in 2005 to that in 2008?
Offer a very short reply. 1.09. What is the ratio of the Expenses (% of total expenses) in Guatemala in 2005 to that in 2008?
Provide a succinct answer. 0.96. What is the ratio of the Expenses (% of total expenses) in New Zealand in 2005 to that in 2008?
Give a very brief answer. 0.97. What is the ratio of the Expenses (% of total expenses) in High income: nonOECD in 2006 to that in 2007?
Your answer should be compact. 0.86. What is the ratio of the Expenses (% of total expenses) of Greece in 2006 to that in 2007?
Offer a terse response. 1.03. What is the ratio of the Expenses (% of total expenses) of Guatemala in 2006 to that in 2007?
Ensure brevity in your answer.  1.01. What is the ratio of the Expenses (% of total expenses) of New Zealand in 2006 to that in 2007?
Give a very brief answer. 1.03. What is the ratio of the Expenses (% of total expenses) in High income: nonOECD in 2006 to that in 2008?
Ensure brevity in your answer.  0.95. What is the ratio of the Expenses (% of total expenses) in Greece in 2006 to that in 2008?
Make the answer very short. 1.04. What is the ratio of the Expenses (% of total expenses) of Guatemala in 2006 to that in 2008?
Make the answer very short. 0.96. What is the ratio of the Expenses (% of total expenses) of New Zealand in 2006 to that in 2008?
Keep it short and to the point. 0.97. What is the ratio of the Expenses (% of total expenses) in High income: nonOECD in 2007 to that in 2008?
Ensure brevity in your answer.  1.11. What is the ratio of the Expenses (% of total expenses) of Greece in 2007 to that in 2008?
Keep it short and to the point. 1.01. What is the ratio of the Expenses (% of total expenses) in Guatemala in 2007 to that in 2008?
Give a very brief answer. 0.94. What is the ratio of the Expenses (% of total expenses) in New Zealand in 2007 to that in 2008?
Your response must be concise. 0.94. What is the difference between the highest and the second highest Expenses (% of total expenses) of High income: nonOECD?
Provide a short and direct response. 1.01. What is the difference between the highest and the second highest Expenses (% of total expenses) of Greece?
Ensure brevity in your answer.  0.24. What is the difference between the highest and the second highest Expenses (% of total expenses) in Guatemala?
Make the answer very short. 1.07. What is the difference between the highest and the second highest Expenses (% of total expenses) of New Zealand?
Provide a succinct answer. 0.69. What is the difference between the highest and the lowest Expenses (% of total expenses) in High income: nonOECD?
Make the answer very short. 3.79. What is the difference between the highest and the lowest Expenses (% of total expenses) of Greece?
Keep it short and to the point. 2.09. What is the difference between the highest and the lowest Expenses (% of total expenses) in Guatemala?
Offer a very short reply. 3.03. What is the difference between the highest and the lowest Expenses (% of total expenses) of New Zealand?
Your response must be concise. 2.34. 